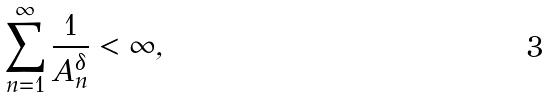<formula> <loc_0><loc_0><loc_500><loc_500>\sum _ { n = 1 } ^ { \infty } \frac { 1 } { A _ { n } ^ { \delta } } < \infty ,</formula> 